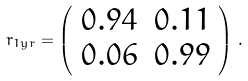Convert formula to latex. <formula><loc_0><loc_0><loc_500><loc_500>r _ { 1 y r } = \left ( \begin{array} { c c } 0 . 9 4 & 0 . 1 1 \\ 0 . 0 6 & 0 . 9 9 \end{array} \right ) \, .</formula> 